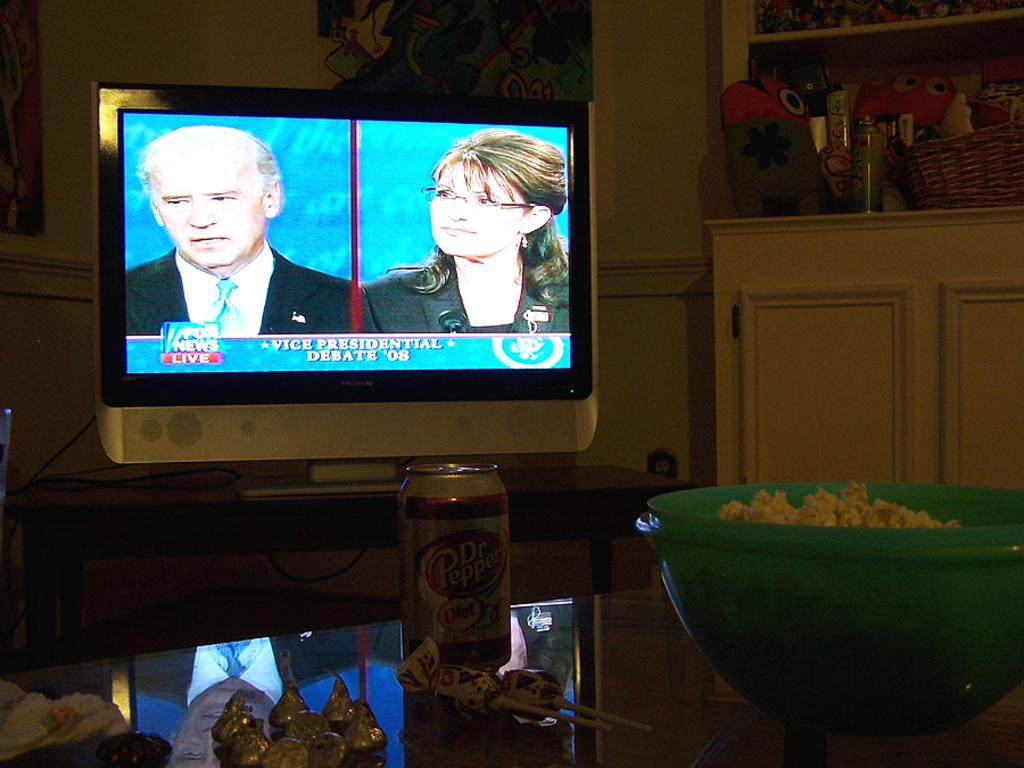<image>
Share a concise interpretation of the image provided. The 2008 vice presidential debate is on the television. 